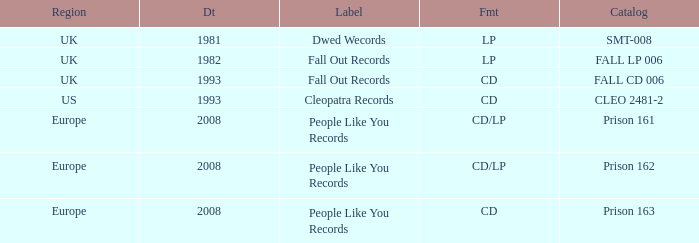Which Label has a Date smaller than 2008, and a Catalog of fall cd 006? Fall Out Records. 